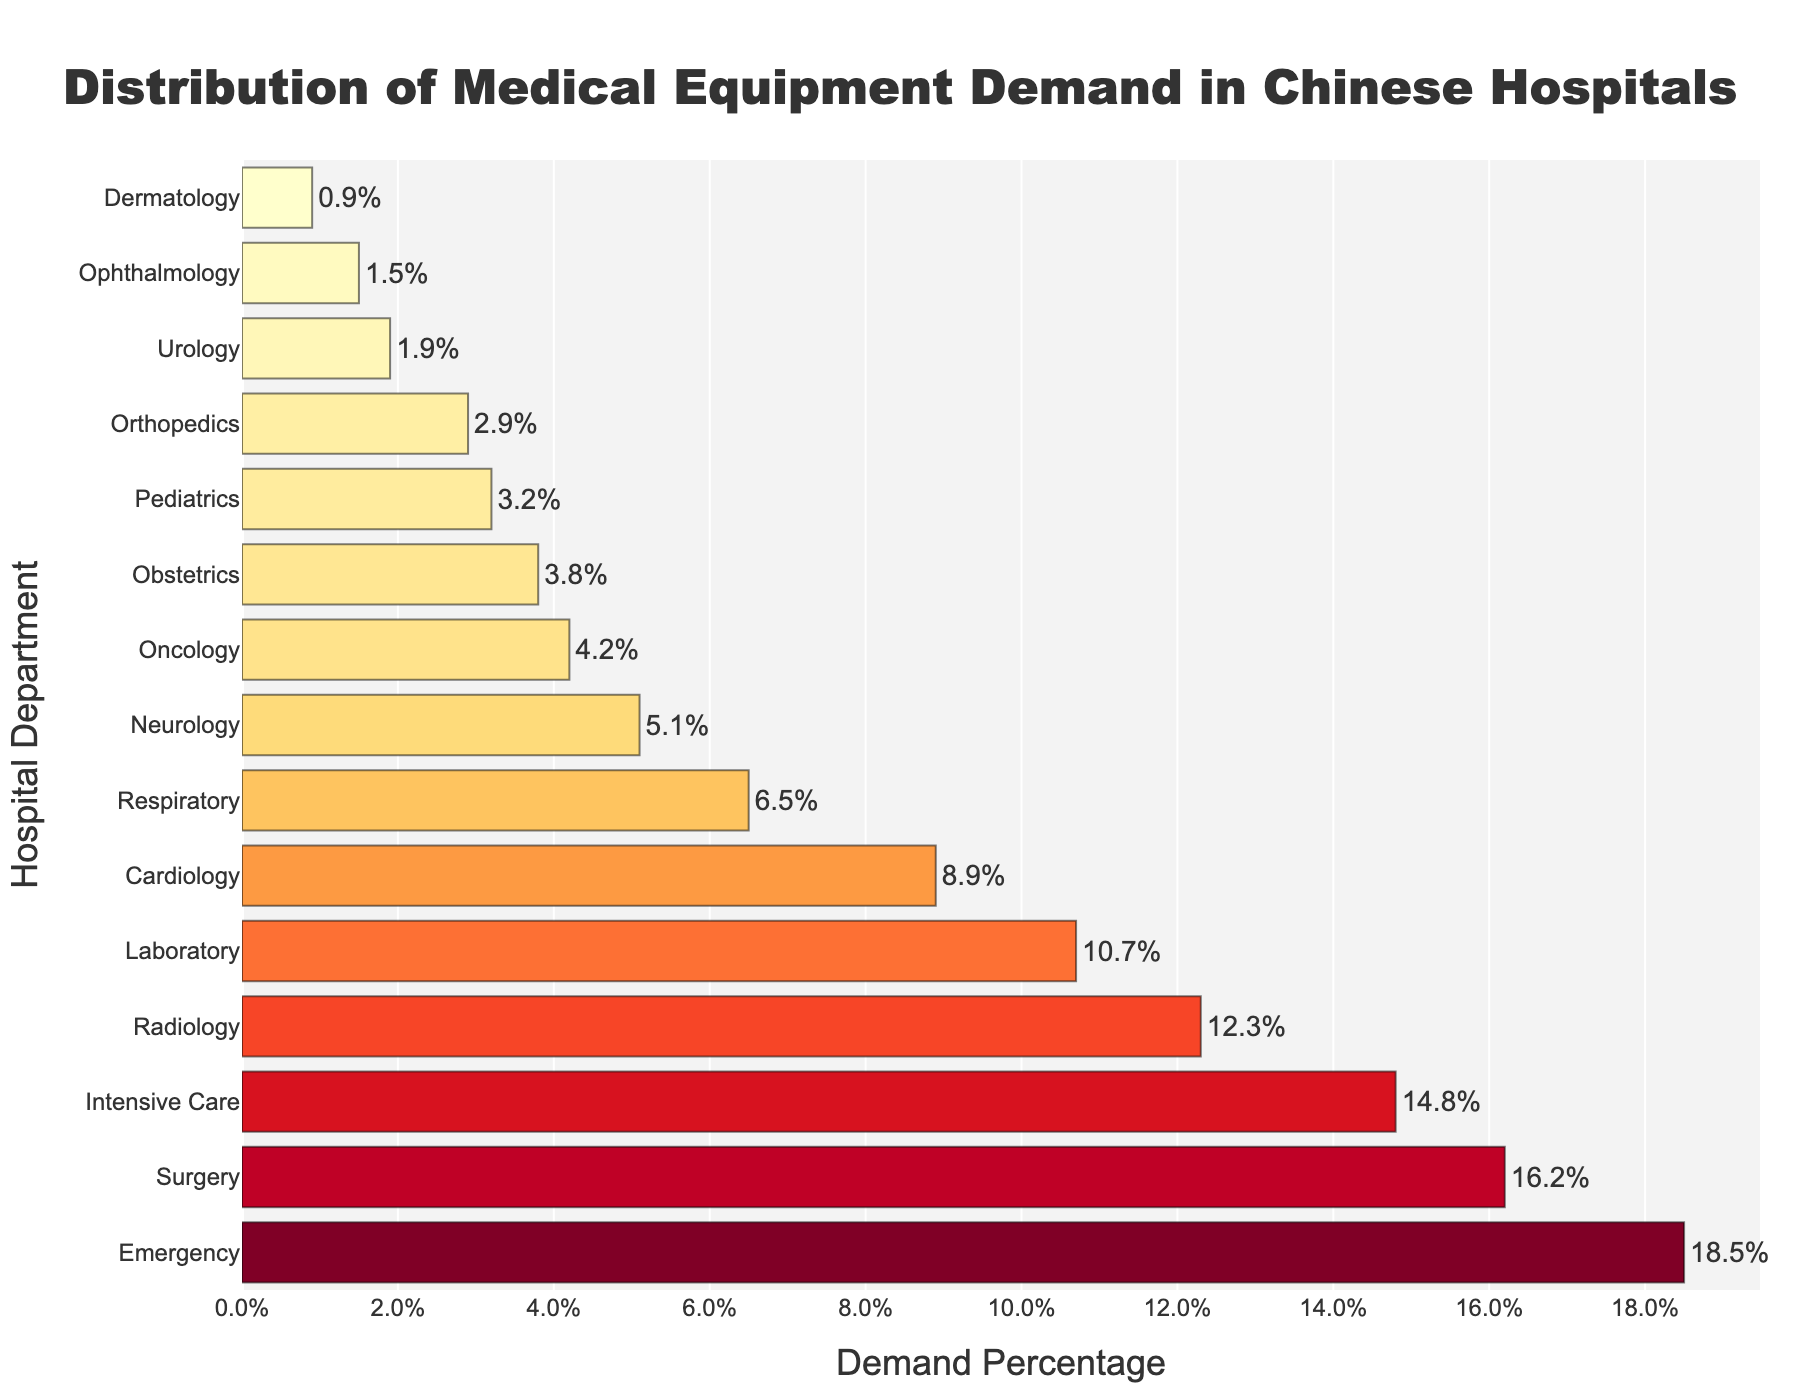Which hospital department has the highest demand for medical equipment? The bar representing the Emergency department is the tallest, indicating it has the highest demand.
Answer: Emergency Which department shows the lowest demand for medical equipment, and what is its percentage? The bar representing Dermatology is the shortest, indicating it has the lowest demand. The percentage shown is 0.9%.
Answer: Dermatology, 0.9% What is the combined demand percentage of Emergency, Surgery, and Intensive Care departments? Adding up the demand percentages: 18.5% (Emergency) + 16.2% (Surgery) + 14.8% (Intensive Care) = 49.5%.
Answer: 49.5% How does the demand for medical equipment in the Radiology department compare to the Oncology department? The bar for Radiology (12.3%) is much larger than that for Oncology (4.2%), indicating Radiology has a higher demand for medical equipment than Oncology.
Answer: Radiology > Oncology What is the average demand percentage across all departments? Summing all demand percentages: 18.5 + 16.2 + 14.8 + 12.3 + 10.7 + 8.9 + 6.5 + 5.1 + 4.2 + 3.8 + 3.2 + 2.9 + 1.9 + 1.5 + 0.9 = 111.4. Dividing by the number of departments (15): 111.4 / 15 = 7.4267, approximately 7.4%.
Answer: 7.4% What is the difference in demand percentage between the highest (Emergency) and the lowest (Dermatology) demanding departments? Subtracting the demand percentage of Dermatology from Emergency: 18.5% - 0.9% = 17.6%.
Answer: 17.6% Which department has a demand closest to 10%, and what is its actual percentage? The Laboratory department has a demand closest to 10%, with an actual demand percentage of 10.7%.
Answer: Laboratory, 10.7% How do the demands for the Cardiology and Respiratory departments compare to each other as well as to the mean demand across all departments? The mean demand is approximately 7.4%. Cardiology has a demand of 8.9%, which is higher than the mean. Respiratory has a demand of 6.5%, which is lower than the mean. Comparing Cardiology (8.9%) and Respiratory (6.5%): Cardiology has a higher demand than Respiratory.
Answer: Cardiology > Respiratory, Cardiology > Mean, Respiratory < Mean Which departments have a demand lower than the average demand percentage? Departments with demand lower than 7.4%: Respiratory (6.5%), Neurology (5.1%), Oncology (4.2%), Obstetrics (3.8%), Pediatrics (3.2%), Orthopedics (2.9%), Urology (1.9%), Ophthalmology (1.5%), Dermatology (0.9%).
Answer: Respiratory, Neurology, Oncology, Obstetrics, Pediatrics, Orthopedics, Urology, Ophthalmology, Dermatology Which departments fall between 5% and 10% in demand for medical equipment, inclusive? The fields within this range include: Cardiology (8.9%), Respiratory (6.5%), and Neurology (5.1%).
Answer: Cardiology, Respiratory, Neurology 